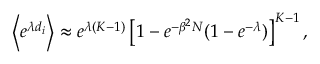<formula> <loc_0><loc_0><loc_500><loc_500>\left \langle e ^ { \lambda d _ { i } } \right \rangle \approx e ^ { \lambda ( K - 1 ) } \left [ 1 - e ^ { - \beta ^ { 2 } N } ( 1 - e ^ { - \lambda } ) \right ] ^ { K - 1 } ,</formula> 